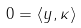<formula> <loc_0><loc_0><loc_500><loc_500>0 = \langle y , \kappa \rangle</formula> 